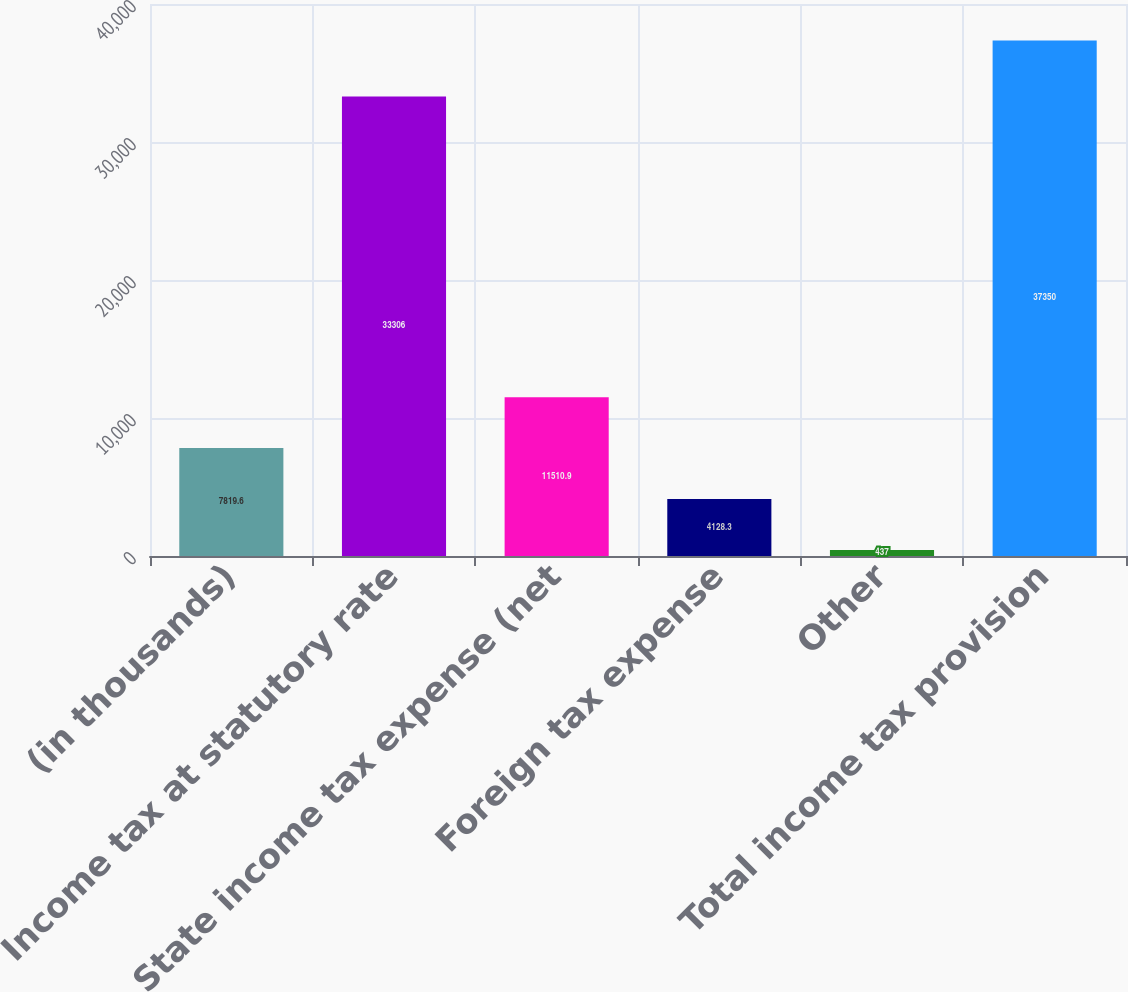<chart> <loc_0><loc_0><loc_500><loc_500><bar_chart><fcel>(in thousands)<fcel>Income tax at statutory rate<fcel>State income tax expense (net<fcel>Foreign tax expense<fcel>Other<fcel>Total income tax provision<nl><fcel>7819.6<fcel>33306<fcel>11510.9<fcel>4128.3<fcel>437<fcel>37350<nl></chart> 